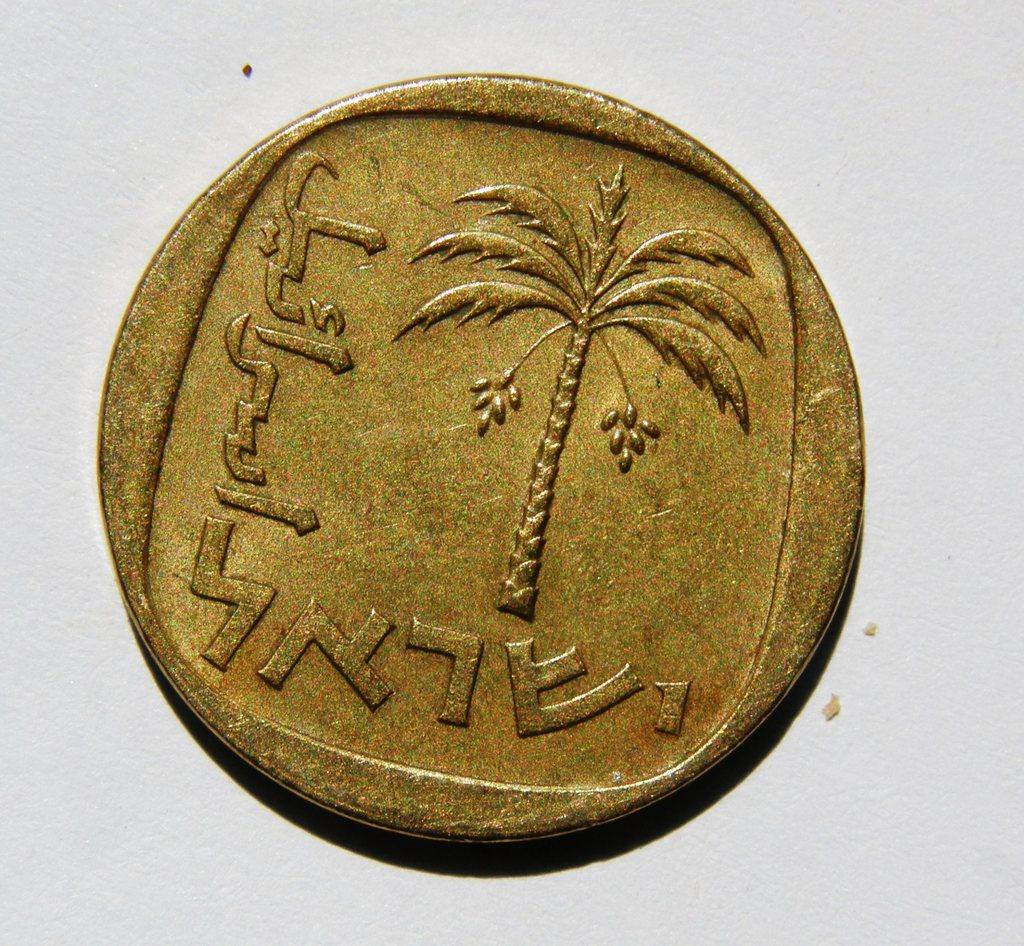<image>
Describe the image concisely. a golden coin with a palm tree on it with strange lettering 